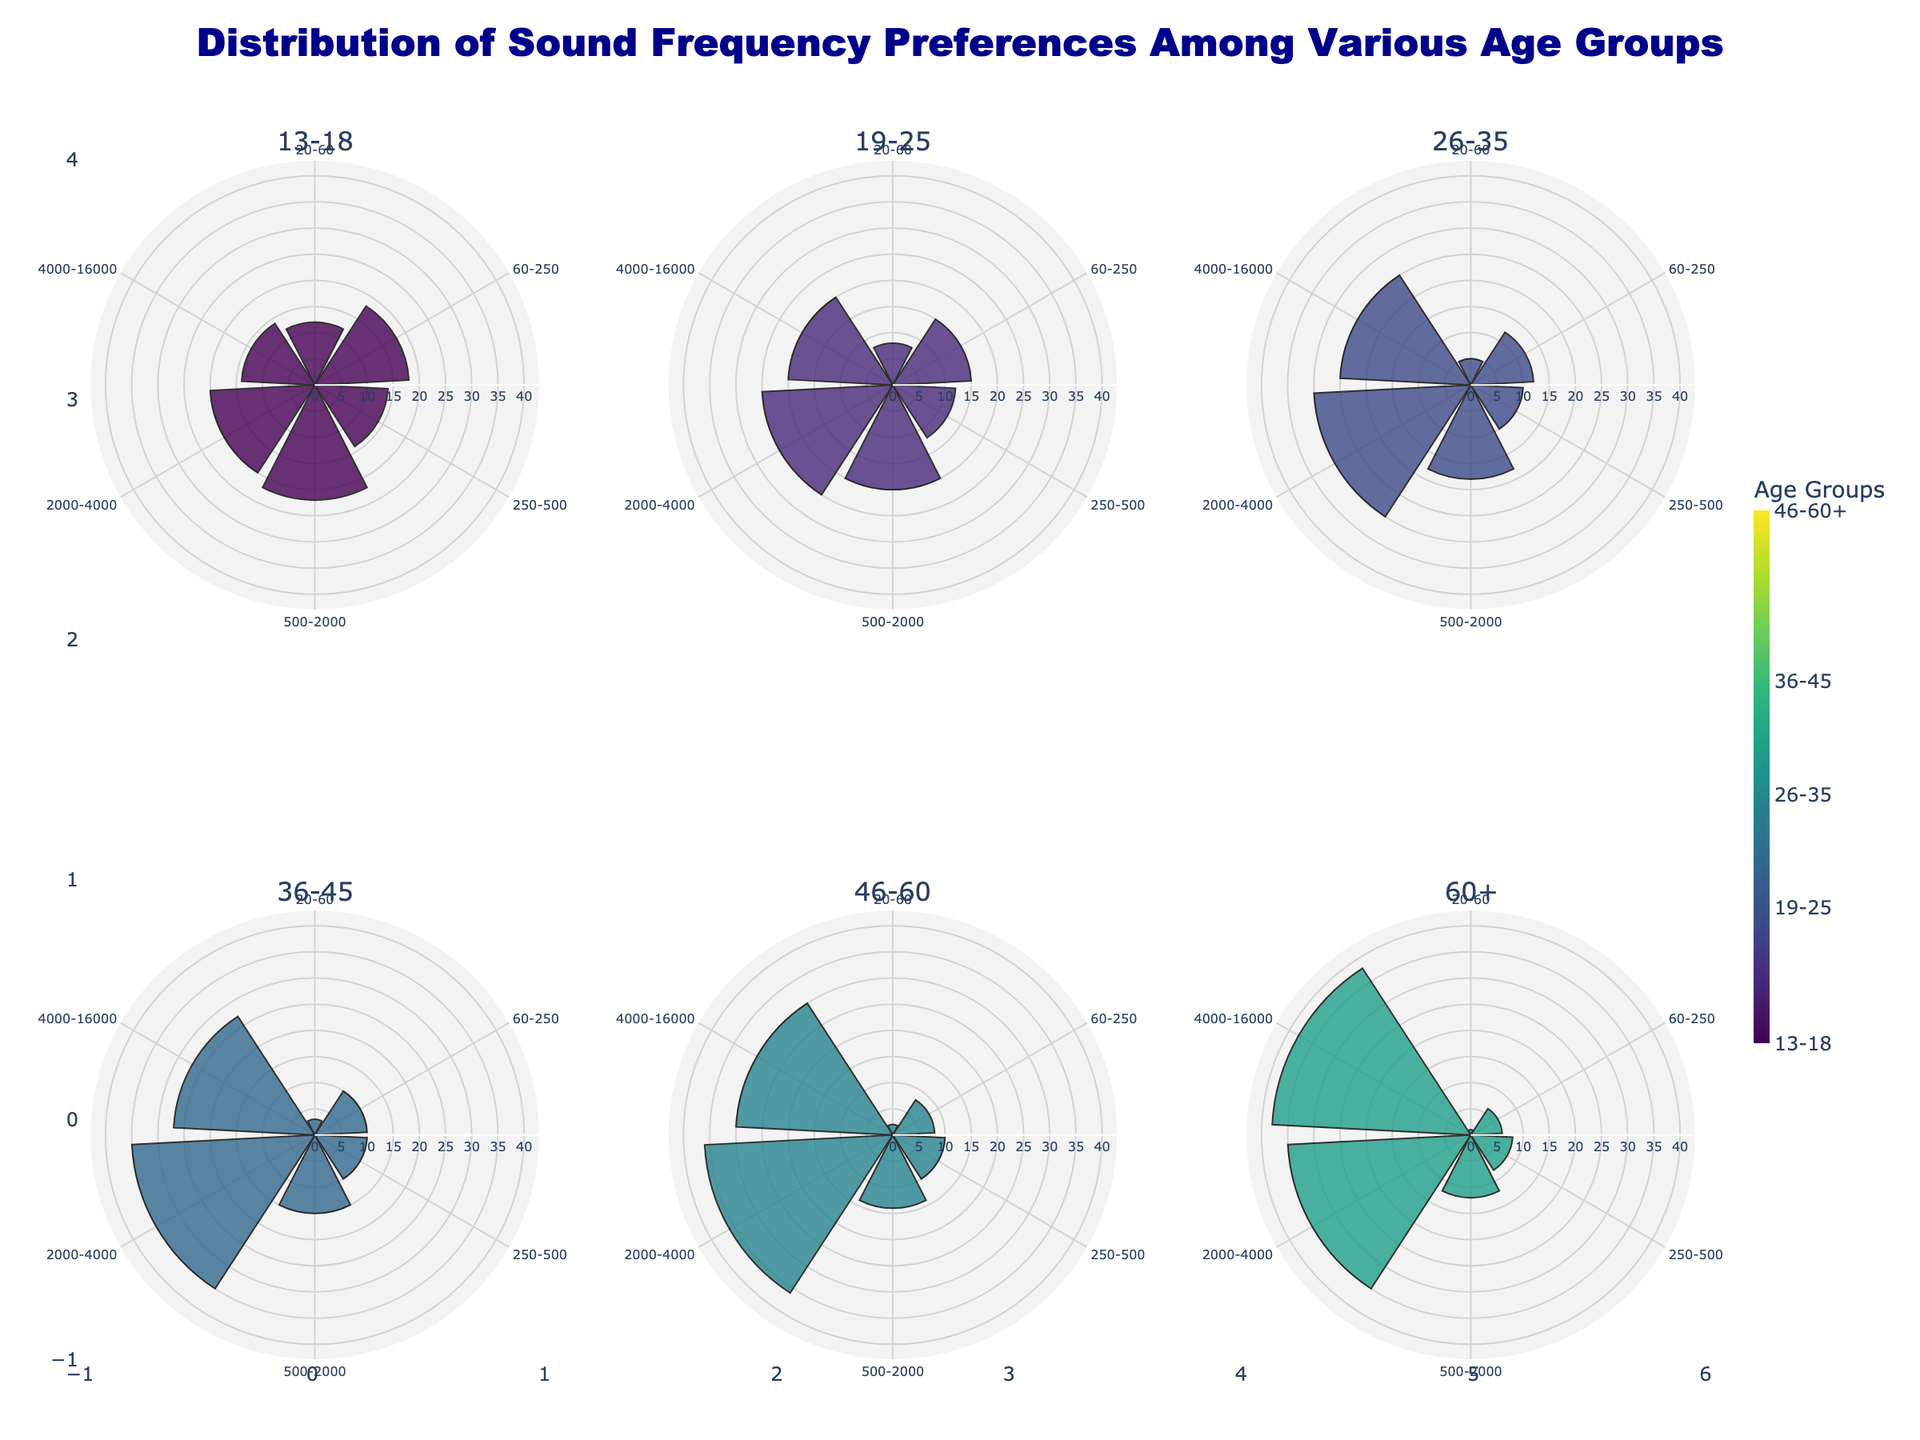What is the title of the figure? The title is located at the top of the figure. It reads "Distribution of Sound Frequency Preferences Among Various Age Groups."
Answer: Distribution of Sound Frequency Preferences Among Various Age Groups Which age group has the highest percentage preference for the 2000-4000 Hz frequency range? By looking at the figure, the highest percentage preference for the 2000-4000 Hz range can be seen in the subplots. The 46-60 age group shows the highest value in this frequency range with 36%.
Answer: 46-60 What is the percentage preference difference between age groups 19-25 and 60+ for the 500-2000 Hz frequency range? The figure shows 20% preference for the 19-25 age group and 12% for the 60+ age group in the 500-2000 Hz range. The difference is 20% - 12% = 8%.
Answer: 8% Which frequency range is most preferred by the 13-18 age group? The maximum percentage preference for the 13-18 age group is observed in the 500-2000 Hz range with 22%.
Answer: 500-2000 Hz How does the preference for the 20-60 Hz frequency range vary across all age groups? Looking at each subplot for the different age groups, the preferences are 12%, 8%, 5%, 3%, 2%, and 1% respectively.
Answer: 12%, 8%, 5%, 3%, 2%, 1% What is the average percentage preference for the 4000-16000 Hz frequency range across all age groups? Sum up the percentage preferences (14 + 20 + 25 + 27 + 30 + 38) in the 4000-16000 Hz range and divide by the number of age groups (6). (14 + 20 + 25 + 27 + 30 + 38) / 6 = 25.67.
Answer: 25.67 Which frequency range shows the greatest variation in preferences among all the age groups? To determine variation, look at the range between the minimum and maximum values for each frequency range across all age groups. The 4000-16000 Hz range shows the greatest spread (minimum 14%, maximum 38%) resulting in a range of 24%.
Answer: 4000-16000 Hz What is the combined preference percentage for the 250-500 Hz frequency range for the age groups 36-45 and 46-60? Add the percentages for the age groups 36-45 (10%) and 46-60 (10%) in the 250-500 Hz range: 10% + 10% = 20%.
Answer: 20% Which age group prefers higher frequencies (2000-16000 Hz) the most? By examining the figure, the 60+ age group shows the highest combined preference for the 2000-4000 Hz and 4000-16000 Hz ranges (35% + 38% = 73%).
Answer: 60+ 